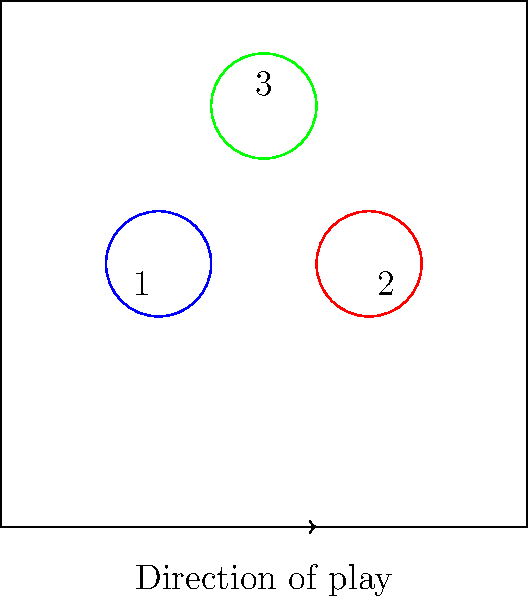In the diagram above, three players are positioned on a basketball court. Player 1 (blue) has possession of the ball and is dribbling towards the basket. Player 2 (red) is defending, and Player 3 (green) is setting a screen. If Player 1 dribbles the ball into Player 2's outstretched arm, which is in a natural defensive position, how should this situation be interpreted according to the rules of basketball? To interpret this situation correctly, we need to consider several factors:

1. Player positioning: Player 1 (offense) is dribbling towards Player 2 (defense).

2. Defensive stance: Player 2's arm is described as outstretched and in a natural defensive position.

3. Contact initiation: Player 1 dribbles the ball into Player 2's arm.

4. Rules regarding hand-checking and defensive position:
   a) Defenders are allowed to maintain a legal guarding position.
   b) Incidental contact is generally allowed when the defender is in a legal position.
   c) The offense is responsible for avoiding contact with a legally positioned defender.

5. Ball handling rules:
   a) The dribbler is allowed protection of the space in front of them.
   b) However, this protection doesn't extend to creating contact with a legally positioned defender.

6. Interpretation:
   - Since Player 2's arm is in a natural defensive position, and Player 1 initiates the contact by dribbling into it, this would typically not be called as a foul on the defender.
   - The contact is considered incidental and a result of the offensive player's actions.

7. Outcome:
   - Play should continue without a whistle unless the contact is severe enough to affect the dribbler's speed, quickness, balance, or rhythm.

Given these considerations, the correct interpretation is that this is a no-call situation, and play should continue.
Answer: No-call; play on 